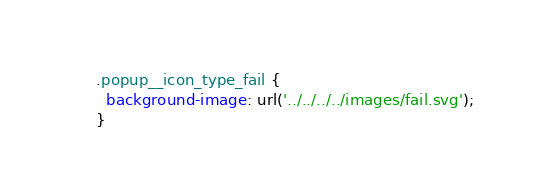Convert code to text. <code><loc_0><loc_0><loc_500><loc_500><_CSS_>.popup__icon_type_fail {
  background-image: url('../../../../images/fail.svg');
}</code> 